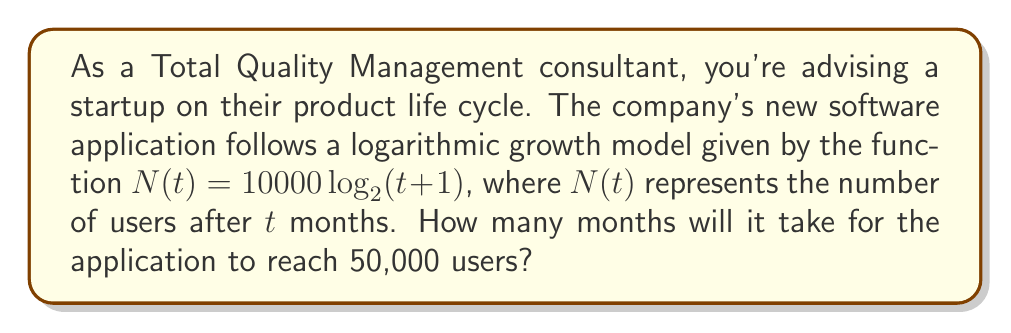Help me with this question. Let's approach this step-by-step:

1) We're given the function $N(t) = 10000 \log_2(t+1)$, where $N(t)$ is the number of users and $t$ is time in months.

2) We want to find $t$ when $N(t) = 50000$. So, let's set up the equation:

   $50000 = 10000 \log_2(t+1)$

3) Divide both sides by 10000:

   $5 = \log_2(t+1)$

4) To solve for $t$, we need to apply the inverse function of $\log_2$, which is $2^x$:

   $2^5 = t+1$

5) Calculate $2^5$:

   $32 = t+1$

6) Subtract 1 from both sides:

   $31 = t$

Therefore, it will take 31 months for the application to reach 50,000 users.
Answer: 31 months 